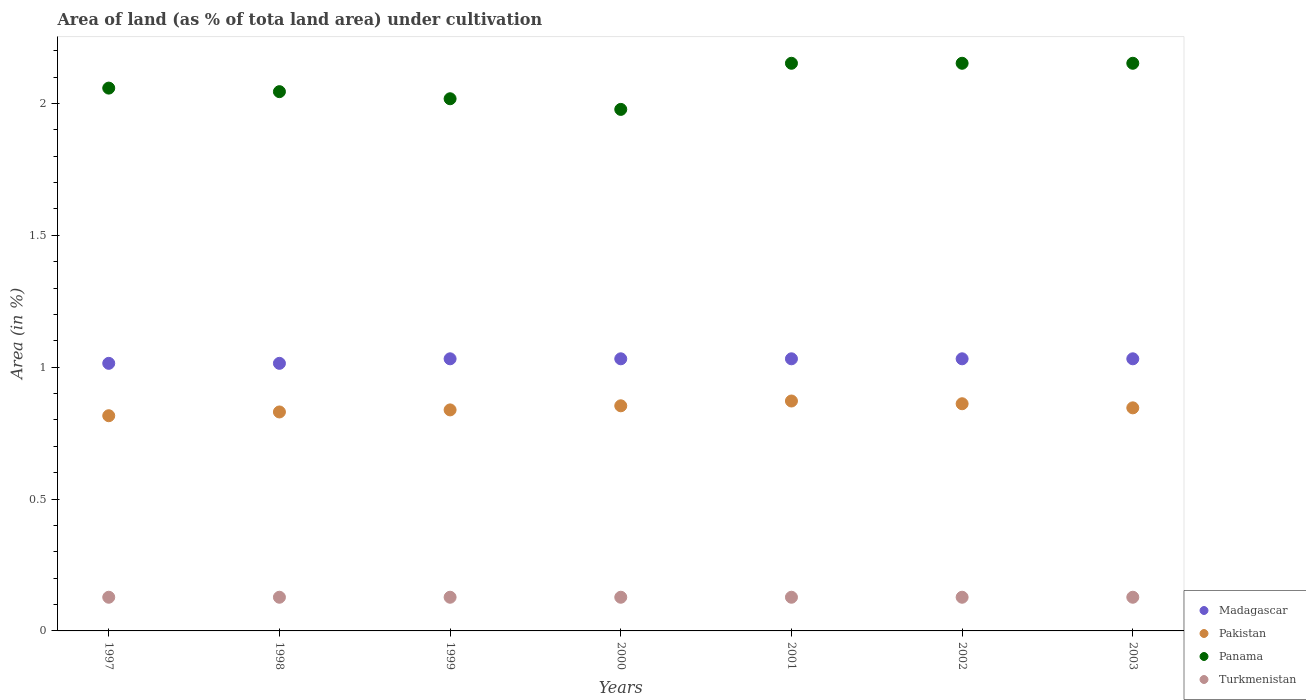What is the percentage of land under cultivation in Panama in 1999?
Give a very brief answer. 2.02. Across all years, what is the maximum percentage of land under cultivation in Turkmenistan?
Offer a terse response. 0.13. Across all years, what is the minimum percentage of land under cultivation in Pakistan?
Make the answer very short. 0.82. What is the total percentage of land under cultivation in Turkmenistan in the graph?
Keep it short and to the point. 0.89. What is the difference between the percentage of land under cultivation in Pakistan in 1998 and that in 2003?
Provide a short and direct response. -0.02. What is the difference between the percentage of land under cultivation in Panama in 1998 and the percentage of land under cultivation in Madagascar in 2003?
Your answer should be compact. 1.01. What is the average percentage of land under cultivation in Madagascar per year?
Your answer should be compact. 1.03. In the year 1999, what is the difference between the percentage of land under cultivation in Madagascar and percentage of land under cultivation in Pakistan?
Keep it short and to the point. 0.19. What is the ratio of the percentage of land under cultivation in Panama in 1998 to that in 2003?
Provide a succinct answer. 0.95. Is the difference between the percentage of land under cultivation in Madagascar in 1999 and 2003 greater than the difference between the percentage of land under cultivation in Pakistan in 1999 and 2003?
Ensure brevity in your answer.  Yes. What is the difference between the highest and the second highest percentage of land under cultivation in Panama?
Your response must be concise. 0. What is the difference between the highest and the lowest percentage of land under cultivation in Madagascar?
Offer a terse response. 0.02. Is it the case that in every year, the sum of the percentage of land under cultivation in Turkmenistan and percentage of land under cultivation in Panama  is greater than the sum of percentage of land under cultivation in Pakistan and percentage of land under cultivation in Madagascar?
Your answer should be compact. Yes. Is the percentage of land under cultivation in Pakistan strictly less than the percentage of land under cultivation in Madagascar over the years?
Your response must be concise. Yes. How many dotlines are there?
Ensure brevity in your answer.  4. What is the difference between two consecutive major ticks on the Y-axis?
Offer a terse response. 0.5. Does the graph contain any zero values?
Ensure brevity in your answer.  No. How many legend labels are there?
Ensure brevity in your answer.  4. How are the legend labels stacked?
Give a very brief answer. Vertical. What is the title of the graph?
Your response must be concise. Area of land (as % of tota land area) under cultivation. What is the label or title of the Y-axis?
Make the answer very short. Area (in %). What is the Area (in %) in Madagascar in 1997?
Keep it short and to the point. 1.01. What is the Area (in %) of Pakistan in 1997?
Your answer should be compact. 0.82. What is the Area (in %) of Panama in 1997?
Make the answer very short. 2.06. What is the Area (in %) of Turkmenistan in 1997?
Make the answer very short. 0.13. What is the Area (in %) of Madagascar in 1998?
Your answer should be compact. 1.01. What is the Area (in %) in Pakistan in 1998?
Your answer should be very brief. 0.83. What is the Area (in %) of Panama in 1998?
Offer a terse response. 2.04. What is the Area (in %) of Turkmenistan in 1998?
Your answer should be compact. 0.13. What is the Area (in %) of Madagascar in 1999?
Offer a terse response. 1.03. What is the Area (in %) of Pakistan in 1999?
Give a very brief answer. 0.84. What is the Area (in %) of Panama in 1999?
Your answer should be very brief. 2.02. What is the Area (in %) in Turkmenistan in 1999?
Ensure brevity in your answer.  0.13. What is the Area (in %) of Madagascar in 2000?
Give a very brief answer. 1.03. What is the Area (in %) of Pakistan in 2000?
Provide a succinct answer. 0.85. What is the Area (in %) of Panama in 2000?
Your answer should be compact. 1.98. What is the Area (in %) in Turkmenistan in 2000?
Your answer should be compact. 0.13. What is the Area (in %) of Madagascar in 2001?
Give a very brief answer. 1.03. What is the Area (in %) of Pakistan in 2001?
Your answer should be very brief. 0.87. What is the Area (in %) of Panama in 2001?
Make the answer very short. 2.15. What is the Area (in %) of Turkmenistan in 2001?
Offer a terse response. 0.13. What is the Area (in %) in Madagascar in 2002?
Provide a succinct answer. 1.03. What is the Area (in %) of Pakistan in 2002?
Ensure brevity in your answer.  0.86. What is the Area (in %) in Panama in 2002?
Provide a short and direct response. 2.15. What is the Area (in %) of Turkmenistan in 2002?
Provide a short and direct response. 0.13. What is the Area (in %) in Madagascar in 2003?
Provide a succinct answer. 1.03. What is the Area (in %) of Pakistan in 2003?
Your answer should be very brief. 0.85. What is the Area (in %) of Panama in 2003?
Ensure brevity in your answer.  2.15. What is the Area (in %) of Turkmenistan in 2003?
Provide a short and direct response. 0.13. Across all years, what is the maximum Area (in %) of Madagascar?
Provide a succinct answer. 1.03. Across all years, what is the maximum Area (in %) of Pakistan?
Your response must be concise. 0.87. Across all years, what is the maximum Area (in %) in Panama?
Offer a terse response. 2.15. Across all years, what is the maximum Area (in %) of Turkmenistan?
Keep it short and to the point. 0.13. Across all years, what is the minimum Area (in %) of Madagascar?
Provide a succinct answer. 1.01. Across all years, what is the minimum Area (in %) of Pakistan?
Keep it short and to the point. 0.82. Across all years, what is the minimum Area (in %) of Panama?
Your answer should be very brief. 1.98. Across all years, what is the minimum Area (in %) of Turkmenistan?
Provide a succinct answer. 0.13. What is the total Area (in %) of Madagascar in the graph?
Keep it short and to the point. 7.19. What is the total Area (in %) in Pakistan in the graph?
Keep it short and to the point. 5.92. What is the total Area (in %) of Panama in the graph?
Give a very brief answer. 14.55. What is the total Area (in %) of Turkmenistan in the graph?
Make the answer very short. 0.89. What is the difference between the Area (in %) in Madagascar in 1997 and that in 1998?
Make the answer very short. 0. What is the difference between the Area (in %) of Pakistan in 1997 and that in 1998?
Provide a succinct answer. -0.01. What is the difference between the Area (in %) in Panama in 1997 and that in 1998?
Ensure brevity in your answer.  0.01. What is the difference between the Area (in %) of Turkmenistan in 1997 and that in 1998?
Your answer should be very brief. 0. What is the difference between the Area (in %) of Madagascar in 1997 and that in 1999?
Offer a very short reply. -0.02. What is the difference between the Area (in %) of Pakistan in 1997 and that in 1999?
Provide a succinct answer. -0.02. What is the difference between the Area (in %) of Panama in 1997 and that in 1999?
Keep it short and to the point. 0.04. What is the difference between the Area (in %) of Turkmenistan in 1997 and that in 1999?
Keep it short and to the point. 0. What is the difference between the Area (in %) of Madagascar in 1997 and that in 2000?
Your response must be concise. -0.02. What is the difference between the Area (in %) of Pakistan in 1997 and that in 2000?
Provide a succinct answer. -0.04. What is the difference between the Area (in %) in Panama in 1997 and that in 2000?
Your answer should be compact. 0.08. What is the difference between the Area (in %) of Turkmenistan in 1997 and that in 2000?
Offer a terse response. 0. What is the difference between the Area (in %) in Madagascar in 1997 and that in 2001?
Your answer should be very brief. -0.02. What is the difference between the Area (in %) in Pakistan in 1997 and that in 2001?
Provide a short and direct response. -0.06. What is the difference between the Area (in %) of Panama in 1997 and that in 2001?
Offer a very short reply. -0.09. What is the difference between the Area (in %) of Turkmenistan in 1997 and that in 2001?
Keep it short and to the point. 0. What is the difference between the Area (in %) of Madagascar in 1997 and that in 2002?
Keep it short and to the point. -0.02. What is the difference between the Area (in %) of Pakistan in 1997 and that in 2002?
Give a very brief answer. -0.05. What is the difference between the Area (in %) of Panama in 1997 and that in 2002?
Make the answer very short. -0.09. What is the difference between the Area (in %) in Turkmenistan in 1997 and that in 2002?
Your answer should be very brief. 0. What is the difference between the Area (in %) of Madagascar in 1997 and that in 2003?
Offer a very short reply. -0.02. What is the difference between the Area (in %) in Pakistan in 1997 and that in 2003?
Offer a terse response. -0.03. What is the difference between the Area (in %) of Panama in 1997 and that in 2003?
Offer a very short reply. -0.09. What is the difference between the Area (in %) of Madagascar in 1998 and that in 1999?
Give a very brief answer. -0.02. What is the difference between the Area (in %) in Pakistan in 1998 and that in 1999?
Provide a succinct answer. -0.01. What is the difference between the Area (in %) of Panama in 1998 and that in 1999?
Provide a short and direct response. 0.03. What is the difference between the Area (in %) of Turkmenistan in 1998 and that in 1999?
Keep it short and to the point. 0. What is the difference between the Area (in %) in Madagascar in 1998 and that in 2000?
Your answer should be compact. -0.02. What is the difference between the Area (in %) of Pakistan in 1998 and that in 2000?
Make the answer very short. -0.02. What is the difference between the Area (in %) of Panama in 1998 and that in 2000?
Your response must be concise. 0.07. What is the difference between the Area (in %) in Turkmenistan in 1998 and that in 2000?
Provide a short and direct response. 0. What is the difference between the Area (in %) of Madagascar in 1998 and that in 2001?
Keep it short and to the point. -0.02. What is the difference between the Area (in %) in Pakistan in 1998 and that in 2001?
Ensure brevity in your answer.  -0.04. What is the difference between the Area (in %) in Panama in 1998 and that in 2001?
Keep it short and to the point. -0.11. What is the difference between the Area (in %) of Madagascar in 1998 and that in 2002?
Ensure brevity in your answer.  -0.02. What is the difference between the Area (in %) of Pakistan in 1998 and that in 2002?
Offer a very short reply. -0.03. What is the difference between the Area (in %) of Panama in 1998 and that in 2002?
Offer a terse response. -0.11. What is the difference between the Area (in %) of Turkmenistan in 1998 and that in 2002?
Keep it short and to the point. 0. What is the difference between the Area (in %) of Madagascar in 1998 and that in 2003?
Ensure brevity in your answer.  -0.02. What is the difference between the Area (in %) in Pakistan in 1998 and that in 2003?
Offer a terse response. -0.02. What is the difference between the Area (in %) in Panama in 1998 and that in 2003?
Give a very brief answer. -0.11. What is the difference between the Area (in %) of Pakistan in 1999 and that in 2000?
Offer a very short reply. -0.02. What is the difference between the Area (in %) of Panama in 1999 and that in 2000?
Offer a very short reply. 0.04. What is the difference between the Area (in %) of Turkmenistan in 1999 and that in 2000?
Your answer should be very brief. 0. What is the difference between the Area (in %) in Pakistan in 1999 and that in 2001?
Give a very brief answer. -0.03. What is the difference between the Area (in %) of Panama in 1999 and that in 2001?
Offer a terse response. -0.13. What is the difference between the Area (in %) of Turkmenistan in 1999 and that in 2001?
Keep it short and to the point. 0. What is the difference between the Area (in %) in Pakistan in 1999 and that in 2002?
Ensure brevity in your answer.  -0.02. What is the difference between the Area (in %) of Panama in 1999 and that in 2002?
Your response must be concise. -0.13. What is the difference between the Area (in %) in Turkmenistan in 1999 and that in 2002?
Your response must be concise. 0. What is the difference between the Area (in %) of Pakistan in 1999 and that in 2003?
Your answer should be very brief. -0.01. What is the difference between the Area (in %) of Panama in 1999 and that in 2003?
Your answer should be compact. -0.13. What is the difference between the Area (in %) in Pakistan in 2000 and that in 2001?
Your answer should be compact. -0.02. What is the difference between the Area (in %) in Panama in 2000 and that in 2001?
Your response must be concise. -0.17. What is the difference between the Area (in %) of Madagascar in 2000 and that in 2002?
Your answer should be very brief. 0. What is the difference between the Area (in %) of Pakistan in 2000 and that in 2002?
Give a very brief answer. -0.01. What is the difference between the Area (in %) in Panama in 2000 and that in 2002?
Offer a terse response. -0.17. What is the difference between the Area (in %) in Turkmenistan in 2000 and that in 2002?
Provide a short and direct response. 0. What is the difference between the Area (in %) in Pakistan in 2000 and that in 2003?
Offer a very short reply. 0.01. What is the difference between the Area (in %) of Panama in 2000 and that in 2003?
Keep it short and to the point. -0.17. What is the difference between the Area (in %) in Turkmenistan in 2000 and that in 2003?
Provide a succinct answer. 0. What is the difference between the Area (in %) of Madagascar in 2001 and that in 2002?
Give a very brief answer. 0. What is the difference between the Area (in %) of Pakistan in 2001 and that in 2002?
Keep it short and to the point. 0.01. What is the difference between the Area (in %) of Panama in 2001 and that in 2002?
Keep it short and to the point. 0. What is the difference between the Area (in %) in Pakistan in 2001 and that in 2003?
Offer a very short reply. 0.03. What is the difference between the Area (in %) in Panama in 2001 and that in 2003?
Offer a terse response. 0. What is the difference between the Area (in %) in Turkmenistan in 2001 and that in 2003?
Make the answer very short. 0. What is the difference between the Area (in %) of Pakistan in 2002 and that in 2003?
Offer a very short reply. 0.02. What is the difference between the Area (in %) in Madagascar in 1997 and the Area (in %) in Pakistan in 1998?
Your answer should be very brief. 0.18. What is the difference between the Area (in %) in Madagascar in 1997 and the Area (in %) in Panama in 1998?
Give a very brief answer. -1.03. What is the difference between the Area (in %) in Madagascar in 1997 and the Area (in %) in Turkmenistan in 1998?
Provide a succinct answer. 0.89. What is the difference between the Area (in %) in Pakistan in 1997 and the Area (in %) in Panama in 1998?
Your answer should be very brief. -1.23. What is the difference between the Area (in %) of Pakistan in 1997 and the Area (in %) of Turkmenistan in 1998?
Ensure brevity in your answer.  0.69. What is the difference between the Area (in %) of Panama in 1997 and the Area (in %) of Turkmenistan in 1998?
Make the answer very short. 1.93. What is the difference between the Area (in %) in Madagascar in 1997 and the Area (in %) in Pakistan in 1999?
Make the answer very short. 0.18. What is the difference between the Area (in %) in Madagascar in 1997 and the Area (in %) in Panama in 1999?
Your answer should be compact. -1. What is the difference between the Area (in %) of Madagascar in 1997 and the Area (in %) of Turkmenistan in 1999?
Provide a succinct answer. 0.89. What is the difference between the Area (in %) in Pakistan in 1997 and the Area (in %) in Panama in 1999?
Your answer should be compact. -1.2. What is the difference between the Area (in %) in Pakistan in 1997 and the Area (in %) in Turkmenistan in 1999?
Ensure brevity in your answer.  0.69. What is the difference between the Area (in %) in Panama in 1997 and the Area (in %) in Turkmenistan in 1999?
Offer a terse response. 1.93. What is the difference between the Area (in %) in Madagascar in 1997 and the Area (in %) in Pakistan in 2000?
Your response must be concise. 0.16. What is the difference between the Area (in %) in Madagascar in 1997 and the Area (in %) in Panama in 2000?
Keep it short and to the point. -0.96. What is the difference between the Area (in %) of Madagascar in 1997 and the Area (in %) of Turkmenistan in 2000?
Your answer should be compact. 0.89. What is the difference between the Area (in %) of Pakistan in 1997 and the Area (in %) of Panama in 2000?
Make the answer very short. -1.16. What is the difference between the Area (in %) of Pakistan in 1997 and the Area (in %) of Turkmenistan in 2000?
Your response must be concise. 0.69. What is the difference between the Area (in %) of Panama in 1997 and the Area (in %) of Turkmenistan in 2000?
Your answer should be very brief. 1.93. What is the difference between the Area (in %) of Madagascar in 1997 and the Area (in %) of Pakistan in 2001?
Make the answer very short. 0.14. What is the difference between the Area (in %) in Madagascar in 1997 and the Area (in %) in Panama in 2001?
Keep it short and to the point. -1.14. What is the difference between the Area (in %) of Madagascar in 1997 and the Area (in %) of Turkmenistan in 2001?
Your answer should be very brief. 0.89. What is the difference between the Area (in %) of Pakistan in 1997 and the Area (in %) of Panama in 2001?
Ensure brevity in your answer.  -1.34. What is the difference between the Area (in %) of Pakistan in 1997 and the Area (in %) of Turkmenistan in 2001?
Your answer should be very brief. 0.69. What is the difference between the Area (in %) of Panama in 1997 and the Area (in %) of Turkmenistan in 2001?
Your answer should be very brief. 1.93. What is the difference between the Area (in %) of Madagascar in 1997 and the Area (in %) of Pakistan in 2002?
Give a very brief answer. 0.15. What is the difference between the Area (in %) in Madagascar in 1997 and the Area (in %) in Panama in 2002?
Your answer should be very brief. -1.14. What is the difference between the Area (in %) in Madagascar in 1997 and the Area (in %) in Turkmenistan in 2002?
Ensure brevity in your answer.  0.89. What is the difference between the Area (in %) in Pakistan in 1997 and the Area (in %) in Panama in 2002?
Your response must be concise. -1.34. What is the difference between the Area (in %) in Pakistan in 1997 and the Area (in %) in Turkmenistan in 2002?
Provide a short and direct response. 0.69. What is the difference between the Area (in %) of Panama in 1997 and the Area (in %) of Turkmenistan in 2002?
Offer a very short reply. 1.93. What is the difference between the Area (in %) in Madagascar in 1997 and the Area (in %) in Pakistan in 2003?
Your answer should be compact. 0.17. What is the difference between the Area (in %) of Madagascar in 1997 and the Area (in %) of Panama in 2003?
Provide a short and direct response. -1.14. What is the difference between the Area (in %) in Madagascar in 1997 and the Area (in %) in Turkmenistan in 2003?
Provide a short and direct response. 0.89. What is the difference between the Area (in %) of Pakistan in 1997 and the Area (in %) of Panama in 2003?
Offer a terse response. -1.34. What is the difference between the Area (in %) of Pakistan in 1997 and the Area (in %) of Turkmenistan in 2003?
Make the answer very short. 0.69. What is the difference between the Area (in %) of Panama in 1997 and the Area (in %) of Turkmenistan in 2003?
Your answer should be very brief. 1.93. What is the difference between the Area (in %) in Madagascar in 1998 and the Area (in %) in Pakistan in 1999?
Give a very brief answer. 0.18. What is the difference between the Area (in %) of Madagascar in 1998 and the Area (in %) of Panama in 1999?
Make the answer very short. -1. What is the difference between the Area (in %) of Madagascar in 1998 and the Area (in %) of Turkmenistan in 1999?
Provide a short and direct response. 0.89. What is the difference between the Area (in %) of Pakistan in 1998 and the Area (in %) of Panama in 1999?
Your answer should be compact. -1.19. What is the difference between the Area (in %) of Pakistan in 1998 and the Area (in %) of Turkmenistan in 1999?
Ensure brevity in your answer.  0.7. What is the difference between the Area (in %) of Panama in 1998 and the Area (in %) of Turkmenistan in 1999?
Keep it short and to the point. 1.92. What is the difference between the Area (in %) of Madagascar in 1998 and the Area (in %) of Pakistan in 2000?
Keep it short and to the point. 0.16. What is the difference between the Area (in %) of Madagascar in 1998 and the Area (in %) of Panama in 2000?
Offer a very short reply. -0.96. What is the difference between the Area (in %) of Madagascar in 1998 and the Area (in %) of Turkmenistan in 2000?
Provide a succinct answer. 0.89. What is the difference between the Area (in %) of Pakistan in 1998 and the Area (in %) of Panama in 2000?
Offer a very short reply. -1.15. What is the difference between the Area (in %) of Pakistan in 1998 and the Area (in %) of Turkmenistan in 2000?
Provide a short and direct response. 0.7. What is the difference between the Area (in %) in Panama in 1998 and the Area (in %) in Turkmenistan in 2000?
Offer a terse response. 1.92. What is the difference between the Area (in %) of Madagascar in 1998 and the Area (in %) of Pakistan in 2001?
Offer a terse response. 0.14. What is the difference between the Area (in %) of Madagascar in 1998 and the Area (in %) of Panama in 2001?
Offer a very short reply. -1.14. What is the difference between the Area (in %) in Madagascar in 1998 and the Area (in %) in Turkmenistan in 2001?
Offer a terse response. 0.89. What is the difference between the Area (in %) of Pakistan in 1998 and the Area (in %) of Panama in 2001?
Make the answer very short. -1.32. What is the difference between the Area (in %) in Pakistan in 1998 and the Area (in %) in Turkmenistan in 2001?
Provide a short and direct response. 0.7. What is the difference between the Area (in %) in Panama in 1998 and the Area (in %) in Turkmenistan in 2001?
Provide a succinct answer. 1.92. What is the difference between the Area (in %) in Madagascar in 1998 and the Area (in %) in Pakistan in 2002?
Offer a very short reply. 0.15. What is the difference between the Area (in %) in Madagascar in 1998 and the Area (in %) in Panama in 2002?
Offer a very short reply. -1.14. What is the difference between the Area (in %) of Madagascar in 1998 and the Area (in %) of Turkmenistan in 2002?
Ensure brevity in your answer.  0.89. What is the difference between the Area (in %) of Pakistan in 1998 and the Area (in %) of Panama in 2002?
Your answer should be compact. -1.32. What is the difference between the Area (in %) of Pakistan in 1998 and the Area (in %) of Turkmenistan in 2002?
Your answer should be compact. 0.7. What is the difference between the Area (in %) in Panama in 1998 and the Area (in %) in Turkmenistan in 2002?
Offer a very short reply. 1.92. What is the difference between the Area (in %) in Madagascar in 1998 and the Area (in %) in Pakistan in 2003?
Keep it short and to the point. 0.17. What is the difference between the Area (in %) of Madagascar in 1998 and the Area (in %) of Panama in 2003?
Ensure brevity in your answer.  -1.14. What is the difference between the Area (in %) in Madagascar in 1998 and the Area (in %) in Turkmenistan in 2003?
Provide a succinct answer. 0.89. What is the difference between the Area (in %) in Pakistan in 1998 and the Area (in %) in Panama in 2003?
Your response must be concise. -1.32. What is the difference between the Area (in %) of Pakistan in 1998 and the Area (in %) of Turkmenistan in 2003?
Ensure brevity in your answer.  0.7. What is the difference between the Area (in %) of Panama in 1998 and the Area (in %) of Turkmenistan in 2003?
Your answer should be very brief. 1.92. What is the difference between the Area (in %) of Madagascar in 1999 and the Area (in %) of Pakistan in 2000?
Your answer should be compact. 0.18. What is the difference between the Area (in %) of Madagascar in 1999 and the Area (in %) of Panama in 2000?
Your answer should be very brief. -0.95. What is the difference between the Area (in %) in Madagascar in 1999 and the Area (in %) in Turkmenistan in 2000?
Provide a short and direct response. 0.9. What is the difference between the Area (in %) in Pakistan in 1999 and the Area (in %) in Panama in 2000?
Offer a very short reply. -1.14. What is the difference between the Area (in %) in Pakistan in 1999 and the Area (in %) in Turkmenistan in 2000?
Provide a succinct answer. 0.71. What is the difference between the Area (in %) of Panama in 1999 and the Area (in %) of Turkmenistan in 2000?
Ensure brevity in your answer.  1.89. What is the difference between the Area (in %) in Madagascar in 1999 and the Area (in %) in Pakistan in 2001?
Your response must be concise. 0.16. What is the difference between the Area (in %) in Madagascar in 1999 and the Area (in %) in Panama in 2001?
Your answer should be very brief. -1.12. What is the difference between the Area (in %) of Madagascar in 1999 and the Area (in %) of Turkmenistan in 2001?
Ensure brevity in your answer.  0.9. What is the difference between the Area (in %) of Pakistan in 1999 and the Area (in %) of Panama in 2001?
Offer a terse response. -1.31. What is the difference between the Area (in %) of Pakistan in 1999 and the Area (in %) of Turkmenistan in 2001?
Ensure brevity in your answer.  0.71. What is the difference between the Area (in %) in Panama in 1999 and the Area (in %) in Turkmenistan in 2001?
Your answer should be very brief. 1.89. What is the difference between the Area (in %) of Madagascar in 1999 and the Area (in %) of Pakistan in 2002?
Your response must be concise. 0.17. What is the difference between the Area (in %) of Madagascar in 1999 and the Area (in %) of Panama in 2002?
Ensure brevity in your answer.  -1.12. What is the difference between the Area (in %) of Madagascar in 1999 and the Area (in %) of Turkmenistan in 2002?
Make the answer very short. 0.9. What is the difference between the Area (in %) of Pakistan in 1999 and the Area (in %) of Panama in 2002?
Provide a succinct answer. -1.31. What is the difference between the Area (in %) of Pakistan in 1999 and the Area (in %) of Turkmenistan in 2002?
Keep it short and to the point. 0.71. What is the difference between the Area (in %) in Panama in 1999 and the Area (in %) in Turkmenistan in 2002?
Your answer should be compact. 1.89. What is the difference between the Area (in %) of Madagascar in 1999 and the Area (in %) of Pakistan in 2003?
Make the answer very short. 0.19. What is the difference between the Area (in %) in Madagascar in 1999 and the Area (in %) in Panama in 2003?
Offer a very short reply. -1.12. What is the difference between the Area (in %) of Madagascar in 1999 and the Area (in %) of Turkmenistan in 2003?
Ensure brevity in your answer.  0.9. What is the difference between the Area (in %) in Pakistan in 1999 and the Area (in %) in Panama in 2003?
Your answer should be compact. -1.31. What is the difference between the Area (in %) of Pakistan in 1999 and the Area (in %) of Turkmenistan in 2003?
Provide a short and direct response. 0.71. What is the difference between the Area (in %) of Panama in 1999 and the Area (in %) of Turkmenistan in 2003?
Keep it short and to the point. 1.89. What is the difference between the Area (in %) in Madagascar in 2000 and the Area (in %) in Pakistan in 2001?
Give a very brief answer. 0.16. What is the difference between the Area (in %) in Madagascar in 2000 and the Area (in %) in Panama in 2001?
Your answer should be very brief. -1.12. What is the difference between the Area (in %) of Madagascar in 2000 and the Area (in %) of Turkmenistan in 2001?
Provide a short and direct response. 0.9. What is the difference between the Area (in %) of Pakistan in 2000 and the Area (in %) of Panama in 2001?
Offer a very short reply. -1.3. What is the difference between the Area (in %) of Pakistan in 2000 and the Area (in %) of Turkmenistan in 2001?
Offer a very short reply. 0.73. What is the difference between the Area (in %) in Panama in 2000 and the Area (in %) in Turkmenistan in 2001?
Give a very brief answer. 1.85. What is the difference between the Area (in %) in Madagascar in 2000 and the Area (in %) in Pakistan in 2002?
Make the answer very short. 0.17. What is the difference between the Area (in %) of Madagascar in 2000 and the Area (in %) of Panama in 2002?
Keep it short and to the point. -1.12. What is the difference between the Area (in %) in Madagascar in 2000 and the Area (in %) in Turkmenistan in 2002?
Offer a very short reply. 0.9. What is the difference between the Area (in %) in Pakistan in 2000 and the Area (in %) in Panama in 2002?
Keep it short and to the point. -1.3. What is the difference between the Area (in %) in Pakistan in 2000 and the Area (in %) in Turkmenistan in 2002?
Provide a short and direct response. 0.73. What is the difference between the Area (in %) in Panama in 2000 and the Area (in %) in Turkmenistan in 2002?
Provide a succinct answer. 1.85. What is the difference between the Area (in %) of Madagascar in 2000 and the Area (in %) of Pakistan in 2003?
Give a very brief answer. 0.19. What is the difference between the Area (in %) in Madagascar in 2000 and the Area (in %) in Panama in 2003?
Provide a succinct answer. -1.12. What is the difference between the Area (in %) of Madagascar in 2000 and the Area (in %) of Turkmenistan in 2003?
Give a very brief answer. 0.9. What is the difference between the Area (in %) in Pakistan in 2000 and the Area (in %) in Panama in 2003?
Keep it short and to the point. -1.3. What is the difference between the Area (in %) of Pakistan in 2000 and the Area (in %) of Turkmenistan in 2003?
Your answer should be very brief. 0.73. What is the difference between the Area (in %) of Panama in 2000 and the Area (in %) of Turkmenistan in 2003?
Your response must be concise. 1.85. What is the difference between the Area (in %) of Madagascar in 2001 and the Area (in %) of Pakistan in 2002?
Make the answer very short. 0.17. What is the difference between the Area (in %) of Madagascar in 2001 and the Area (in %) of Panama in 2002?
Offer a terse response. -1.12. What is the difference between the Area (in %) in Madagascar in 2001 and the Area (in %) in Turkmenistan in 2002?
Ensure brevity in your answer.  0.9. What is the difference between the Area (in %) in Pakistan in 2001 and the Area (in %) in Panama in 2002?
Give a very brief answer. -1.28. What is the difference between the Area (in %) of Pakistan in 2001 and the Area (in %) of Turkmenistan in 2002?
Ensure brevity in your answer.  0.74. What is the difference between the Area (in %) of Panama in 2001 and the Area (in %) of Turkmenistan in 2002?
Make the answer very short. 2.02. What is the difference between the Area (in %) in Madagascar in 2001 and the Area (in %) in Pakistan in 2003?
Your answer should be compact. 0.19. What is the difference between the Area (in %) of Madagascar in 2001 and the Area (in %) of Panama in 2003?
Offer a very short reply. -1.12. What is the difference between the Area (in %) in Madagascar in 2001 and the Area (in %) in Turkmenistan in 2003?
Provide a succinct answer. 0.9. What is the difference between the Area (in %) of Pakistan in 2001 and the Area (in %) of Panama in 2003?
Offer a terse response. -1.28. What is the difference between the Area (in %) in Pakistan in 2001 and the Area (in %) in Turkmenistan in 2003?
Your answer should be very brief. 0.74. What is the difference between the Area (in %) in Panama in 2001 and the Area (in %) in Turkmenistan in 2003?
Your answer should be compact. 2.02. What is the difference between the Area (in %) in Madagascar in 2002 and the Area (in %) in Pakistan in 2003?
Your answer should be very brief. 0.19. What is the difference between the Area (in %) in Madagascar in 2002 and the Area (in %) in Panama in 2003?
Your answer should be very brief. -1.12. What is the difference between the Area (in %) in Madagascar in 2002 and the Area (in %) in Turkmenistan in 2003?
Your response must be concise. 0.9. What is the difference between the Area (in %) of Pakistan in 2002 and the Area (in %) of Panama in 2003?
Ensure brevity in your answer.  -1.29. What is the difference between the Area (in %) in Pakistan in 2002 and the Area (in %) in Turkmenistan in 2003?
Offer a very short reply. 0.73. What is the difference between the Area (in %) in Panama in 2002 and the Area (in %) in Turkmenistan in 2003?
Offer a terse response. 2.02. What is the average Area (in %) of Madagascar per year?
Offer a very short reply. 1.03. What is the average Area (in %) of Pakistan per year?
Make the answer very short. 0.85. What is the average Area (in %) of Panama per year?
Keep it short and to the point. 2.08. What is the average Area (in %) in Turkmenistan per year?
Provide a succinct answer. 0.13. In the year 1997, what is the difference between the Area (in %) of Madagascar and Area (in %) of Pakistan?
Provide a short and direct response. 0.2. In the year 1997, what is the difference between the Area (in %) of Madagascar and Area (in %) of Panama?
Offer a terse response. -1.04. In the year 1997, what is the difference between the Area (in %) of Madagascar and Area (in %) of Turkmenistan?
Your answer should be compact. 0.89. In the year 1997, what is the difference between the Area (in %) in Pakistan and Area (in %) in Panama?
Keep it short and to the point. -1.24. In the year 1997, what is the difference between the Area (in %) of Pakistan and Area (in %) of Turkmenistan?
Your answer should be very brief. 0.69. In the year 1997, what is the difference between the Area (in %) of Panama and Area (in %) of Turkmenistan?
Make the answer very short. 1.93. In the year 1998, what is the difference between the Area (in %) of Madagascar and Area (in %) of Pakistan?
Provide a succinct answer. 0.18. In the year 1998, what is the difference between the Area (in %) in Madagascar and Area (in %) in Panama?
Offer a very short reply. -1.03. In the year 1998, what is the difference between the Area (in %) of Madagascar and Area (in %) of Turkmenistan?
Give a very brief answer. 0.89. In the year 1998, what is the difference between the Area (in %) in Pakistan and Area (in %) in Panama?
Make the answer very short. -1.21. In the year 1998, what is the difference between the Area (in %) in Pakistan and Area (in %) in Turkmenistan?
Make the answer very short. 0.7. In the year 1998, what is the difference between the Area (in %) of Panama and Area (in %) of Turkmenistan?
Your answer should be very brief. 1.92. In the year 1999, what is the difference between the Area (in %) of Madagascar and Area (in %) of Pakistan?
Your answer should be very brief. 0.19. In the year 1999, what is the difference between the Area (in %) in Madagascar and Area (in %) in Panama?
Offer a very short reply. -0.99. In the year 1999, what is the difference between the Area (in %) of Madagascar and Area (in %) of Turkmenistan?
Your answer should be compact. 0.9. In the year 1999, what is the difference between the Area (in %) in Pakistan and Area (in %) in Panama?
Make the answer very short. -1.18. In the year 1999, what is the difference between the Area (in %) in Pakistan and Area (in %) in Turkmenistan?
Your response must be concise. 0.71. In the year 1999, what is the difference between the Area (in %) in Panama and Area (in %) in Turkmenistan?
Ensure brevity in your answer.  1.89. In the year 2000, what is the difference between the Area (in %) of Madagascar and Area (in %) of Pakistan?
Your response must be concise. 0.18. In the year 2000, what is the difference between the Area (in %) in Madagascar and Area (in %) in Panama?
Offer a very short reply. -0.95. In the year 2000, what is the difference between the Area (in %) of Madagascar and Area (in %) of Turkmenistan?
Provide a succinct answer. 0.9. In the year 2000, what is the difference between the Area (in %) in Pakistan and Area (in %) in Panama?
Your answer should be compact. -1.12. In the year 2000, what is the difference between the Area (in %) of Pakistan and Area (in %) of Turkmenistan?
Provide a succinct answer. 0.73. In the year 2000, what is the difference between the Area (in %) of Panama and Area (in %) of Turkmenistan?
Your response must be concise. 1.85. In the year 2001, what is the difference between the Area (in %) in Madagascar and Area (in %) in Pakistan?
Ensure brevity in your answer.  0.16. In the year 2001, what is the difference between the Area (in %) of Madagascar and Area (in %) of Panama?
Your response must be concise. -1.12. In the year 2001, what is the difference between the Area (in %) in Madagascar and Area (in %) in Turkmenistan?
Offer a very short reply. 0.9. In the year 2001, what is the difference between the Area (in %) in Pakistan and Area (in %) in Panama?
Offer a very short reply. -1.28. In the year 2001, what is the difference between the Area (in %) of Pakistan and Area (in %) of Turkmenistan?
Your answer should be compact. 0.74. In the year 2001, what is the difference between the Area (in %) of Panama and Area (in %) of Turkmenistan?
Your answer should be compact. 2.02. In the year 2002, what is the difference between the Area (in %) in Madagascar and Area (in %) in Pakistan?
Provide a succinct answer. 0.17. In the year 2002, what is the difference between the Area (in %) of Madagascar and Area (in %) of Panama?
Keep it short and to the point. -1.12. In the year 2002, what is the difference between the Area (in %) of Madagascar and Area (in %) of Turkmenistan?
Keep it short and to the point. 0.9. In the year 2002, what is the difference between the Area (in %) in Pakistan and Area (in %) in Panama?
Make the answer very short. -1.29. In the year 2002, what is the difference between the Area (in %) in Pakistan and Area (in %) in Turkmenistan?
Ensure brevity in your answer.  0.73. In the year 2002, what is the difference between the Area (in %) of Panama and Area (in %) of Turkmenistan?
Offer a very short reply. 2.02. In the year 2003, what is the difference between the Area (in %) of Madagascar and Area (in %) of Pakistan?
Ensure brevity in your answer.  0.19. In the year 2003, what is the difference between the Area (in %) of Madagascar and Area (in %) of Panama?
Your answer should be compact. -1.12. In the year 2003, what is the difference between the Area (in %) in Madagascar and Area (in %) in Turkmenistan?
Your answer should be compact. 0.9. In the year 2003, what is the difference between the Area (in %) in Pakistan and Area (in %) in Panama?
Ensure brevity in your answer.  -1.31. In the year 2003, what is the difference between the Area (in %) in Pakistan and Area (in %) in Turkmenistan?
Your response must be concise. 0.72. In the year 2003, what is the difference between the Area (in %) in Panama and Area (in %) in Turkmenistan?
Provide a succinct answer. 2.02. What is the ratio of the Area (in %) of Pakistan in 1997 to that in 1998?
Offer a very short reply. 0.98. What is the ratio of the Area (in %) of Panama in 1997 to that in 1998?
Provide a succinct answer. 1.01. What is the ratio of the Area (in %) of Turkmenistan in 1997 to that in 1998?
Your response must be concise. 1. What is the ratio of the Area (in %) of Madagascar in 1997 to that in 1999?
Provide a succinct answer. 0.98. What is the ratio of the Area (in %) of Pakistan in 1997 to that in 1999?
Give a very brief answer. 0.97. What is the ratio of the Area (in %) of Turkmenistan in 1997 to that in 1999?
Make the answer very short. 1. What is the ratio of the Area (in %) of Madagascar in 1997 to that in 2000?
Your answer should be very brief. 0.98. What is the ratio of the Area (in %) of Pakistan in 1997 to that in 2000?
Keep it short and to the point. 0.96. What is the ratio of the Area (in %) of Panama in 1997 to that in 2000?
Ensure brevity in your answer.  1.04. What is the ratio of the Area (in %) of Turkmenistan in 1997 to that in 2000?
Your answer should be very brief. 1. What is the ratio of the Area (in %) of Madagascar in 1997 to that in 2001?
Keep it short and to the point. 0.98. What is the ratio of the Area (in %) of Pakistan in 1997 to that in 2001?
Offer a very short reply. 0.94. What is the ratio of the Area (in %) of Panama in 1997 to that in 2001?
Provide a succinct answer. 0.96. What is the ratio of the Area (in %) of Madagascar in 1997 to that in 2002?
Make the answer very short. 0.98. What is the ratio of the Area (in %) in Pakistan in 1997 to that in 2002?
Give a very brief answer. 0.95. What is the ratio of the Area (in %) of Panama in 1997 to that in 2002?
Provide a short and direct response. 0.96. What is the ratio of the Area (in %) of Madagascar in 1997 to that in 2003?
Keep it short and to the point. 0.98. What is the ratio of the Area (in %) of Pakistan in 1997 to that in 2003?
Make the answer very short. 0.96. What is the ratio of the Area (in %) of Panama in 1997 to that in 2003?
Offer a very short reply. 0.96. What is the ratio of the Area (in %) of Turkmenistan in 1997 to that in 2003?
Your response must be concise. 1. What is the ratio of the Area (in %) in Madagascar in 1998 to that in 1999?
Keep it short and to the point. 0.98. What is the ratio of the Area (in %) in Pakistan in 1998 to that in 1999?
Make the answer very short. 0.99. What is the ratio of the Area (in %) in Panama in 1998 to that in 1999?
Offer a terse response. 1.01. What is the ratio of the Area (in %) in Turkmenistan in 1998 to that in 1999?
Your answer should be very brief. 1. What is the ratio of the Area (in %) in Madagascar in 1998 to that in 2000?
Keep it short and to the point. 0.98. What is the ratio of the Area (in %) in Pakistan in 1998 to that in 2000?
Your response must be concise. 0.97. What is the ratio of the Area (in %) of Panama in 1998 to that in 2000?
Make the answer very short. 1.03. What is the ratio of the Area (in %) in Turkmenistan in 1998 to that in 2000?
Provide a succinct answer. 1. What is the ratio of the Area (in %) of Madagascar in 1998 to that in 2001?
Your response must be concise. 0.98. What is the ratio of the Area (in %) of Panama in 1998 to that in 2001?
Your response must be concise. 0.95. What is the ratio of the Area (in %) in Madagascar in 1998 to that in 2002?
Your answer should be compact. 0.98. What is the ratio of the Area (in %) in Pakistan in 1998 to that in 2002?
Give a very brief answer. 0.96. What is the ratio of the Area (in %) in Panama in 1998 to that in 2002?
Offer a terse response. 0.95. What is the ratio of the Area (in %) of Turkmenistan in 1998 to that in 2002?
Provide a short and direct response. 1. What is the ratio of the Area (in %) of Madagascar in 1998 to that in 2003?
Provide a succinct answer. 0.98. What is the ratio of the Area (in %) of Pakistan in 1998 to that in 2003?
Your answer should be compact. 0.98. What is the ratio of the Area (in %) of Panama in 1998 to that in 2003?
Offer a terse response. 0.95. What is the ratio of the Area (in %) of Madagascar in 1999 to that in 2000?
Give a very brief answer. 1. What is the ratio of the Area (in %) of Pakistan in 1999 to that in 2000?
Your answer should be compact. 0.98. What is the ratio of the Area (in %) in Panama in 1999 to that in 2000?
Provide a succinct answer. 1.02. What is the ratio of the Area (in %) of Madagascar in 1999 to that in 2001?
Offer a very short reply. 1. What is the ratio of the Area (in %) in Pakistan in 1999 to that in 2001?
Keep it short and to the point. 0.96. What is the ratio of the Area (in %) in Turkmenistan in 1999 to that in 2001?
Your response must be concise. 1. What is the ratio of the Area (in %) of Madagascar in 1999 to that in 2002?
Your answer should be very brief. 1. What is the ratio of the Area (in %) of Pakistan in 1999 to that in 2002?
Provide a succinct answer. 0.97. What is the ratio of the Area (in %) in Turkmenistan in 1999 to that in 2002?
Give a very brief answer. 1. What is the ratio of the Area (in %) of Panama in 1999 to that in 2003?
Keep it short and to the point. 0.94. What is the ratio of the Area (in %) in Pakistan in 2000 to that in 2001?
Give a very brief answer. 0.98. What is the ratio of the Area (in %) of Panama in 2000 to that in 2001?
Ensure brevity in your answer.  0.92. What is the ratio of the Area (in %) of Turkmenistan in 2000 to that in 2001?
Your answer should be compact. 1. What is the ratio of the Area (in %) of Panama in 2000 to that in 2002?
Ensure brevity in your answer.  0.92. What is the ratio of the Area (in %) in Turkmenistan in 2000 to that in 2002?
Offer a terse response. 1. What is the ratio of the Area (in %) of Madagascar in 2000 to that in 2003?
Your answer should be compact. 1. What is the ratio of the Area (in %) of Pakistan in 2000 to that in 2003?
Offer a very short reply. 1.01. What is the ratio of the Area (in %) in Panama in 2000 to that in 2003?
Give a very brief answer. 0.92. What is the ratio of the Area (in %) of Turkmenistan in 2000 to that in 2003?
Your answer should be very brief. 1. What is the ratio of the Area (in %) of Madagascar in 2001 to that in 2002?
Make the answer very short. 1. What is the ratio of the Area (in %) in Madagascar in 2001 to that in 2003?
Provide a short and direct response. 1. What is the ratio of the Area (in %) in Pakistan in 2001 to that in 2003?
Make the answer very short. 1.03. What is the ratio of the Area (in %) in Panama in 2001 to that in 2003?
Your response must be concise. 1. What is the ratio of the Area (in %) in Madagascar in 2002 to that in 2003?
Ensure brevity in your answer.  1. What is the ratio of the Area (in %) of Pakistan in 2002 to that in 2003?
Keep it short and to the point. 1.02. What is the ratio of the Area (in %) in Turkmenistan in 2002 to that in 2003?
Keep it short and to the point. 1. What is the difference between the highest and the second highest Area (in %) of Pakistan?
Offer a very short reply. 0.01. What is the difference between the highest and the lowest Area (in %) of Madagascar?
Your response must be concise. 0.02. What is the difference between the highest and the lowest Area (in %) in Pakistan?
Provide a succinct answer. 0.06. What is the difference between the highest and the lowest Area (in %) of Panama?
Keep it short and to the point. 0.17. What is the difference between the highest and the lowest Area (in %) in Turkmenistan?
Your answer should be compact. 0. 